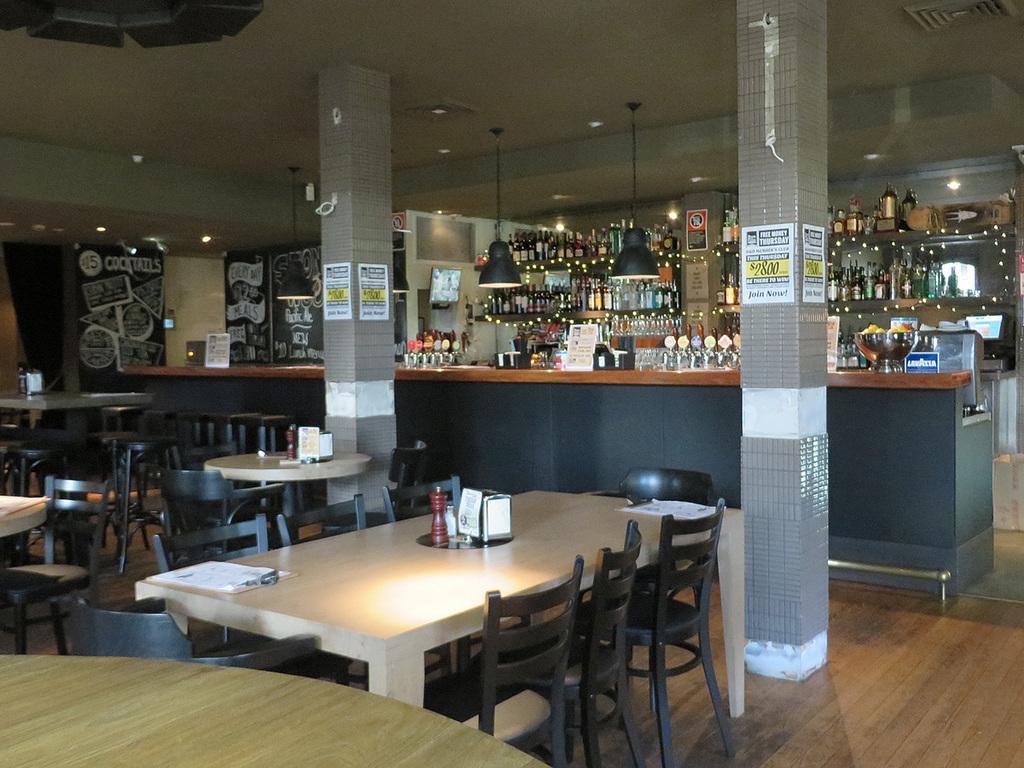Can you describe this image briefly? This is an inside view. On the left side, I can see a table and some empty chairs. In the middle of the image there are two pillars, at the back of it I can see a big table. In the background there are many bottles are arranged in a rack. On the top of the image I can see the lights. 